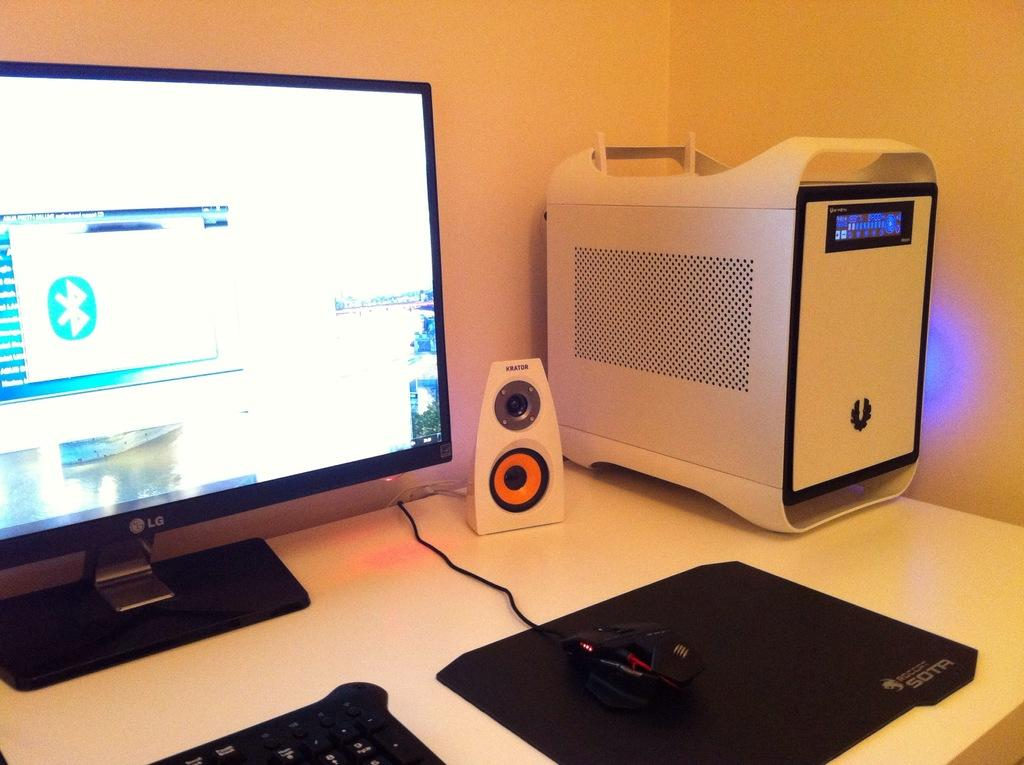<image>
Write a terse but informative summary of the picture. An LG monitor sits next to a speaker and a mouse. 